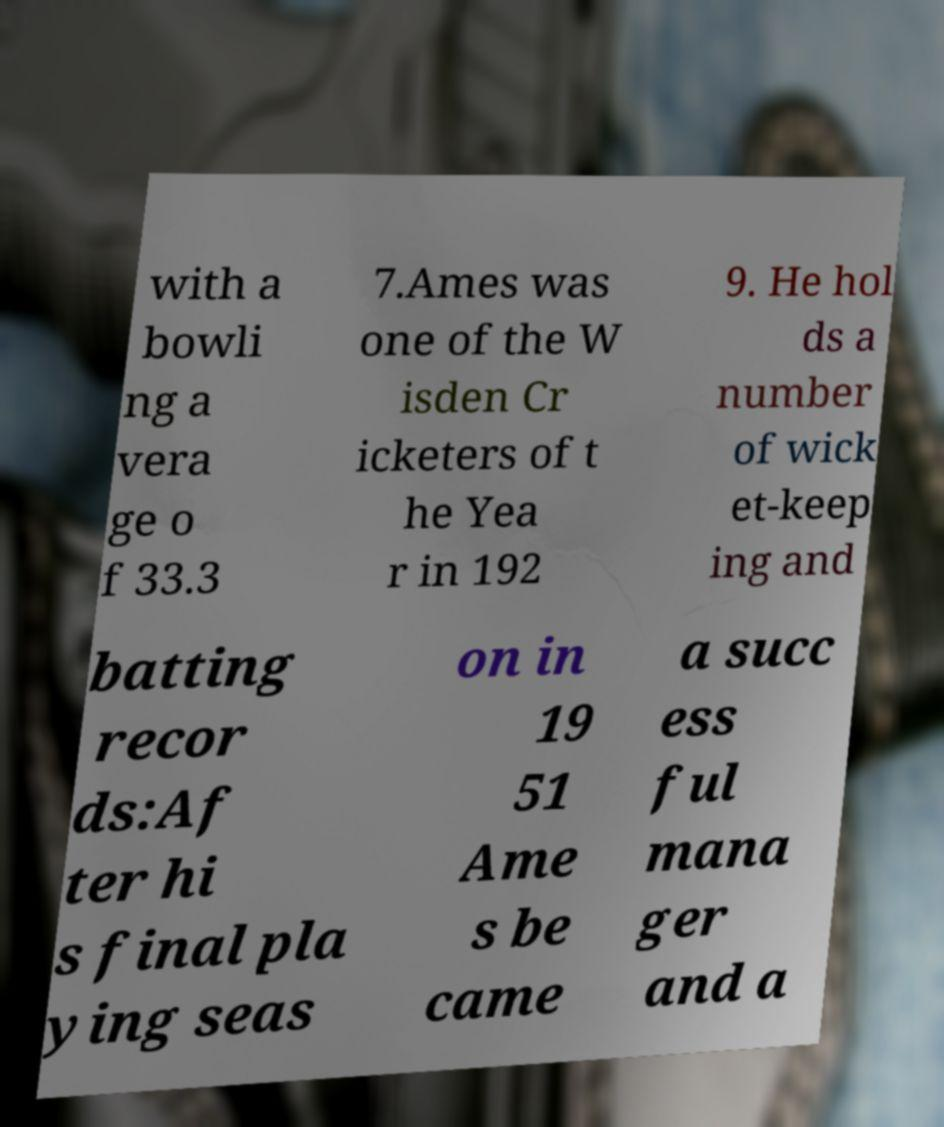Could you assist in decoding the text presented in this image and type it out clearly? with a bowli ng a vera ge o f 33.3 7.Ames was one of the W isden Cr icketers of t he Yea r in 192 9. He hol ds a number of wick et-keep ing and batting recor ds:Af ter hi s final pla ying seas on in 19 51 Ame s be came a succ ess ful mana ger and a 